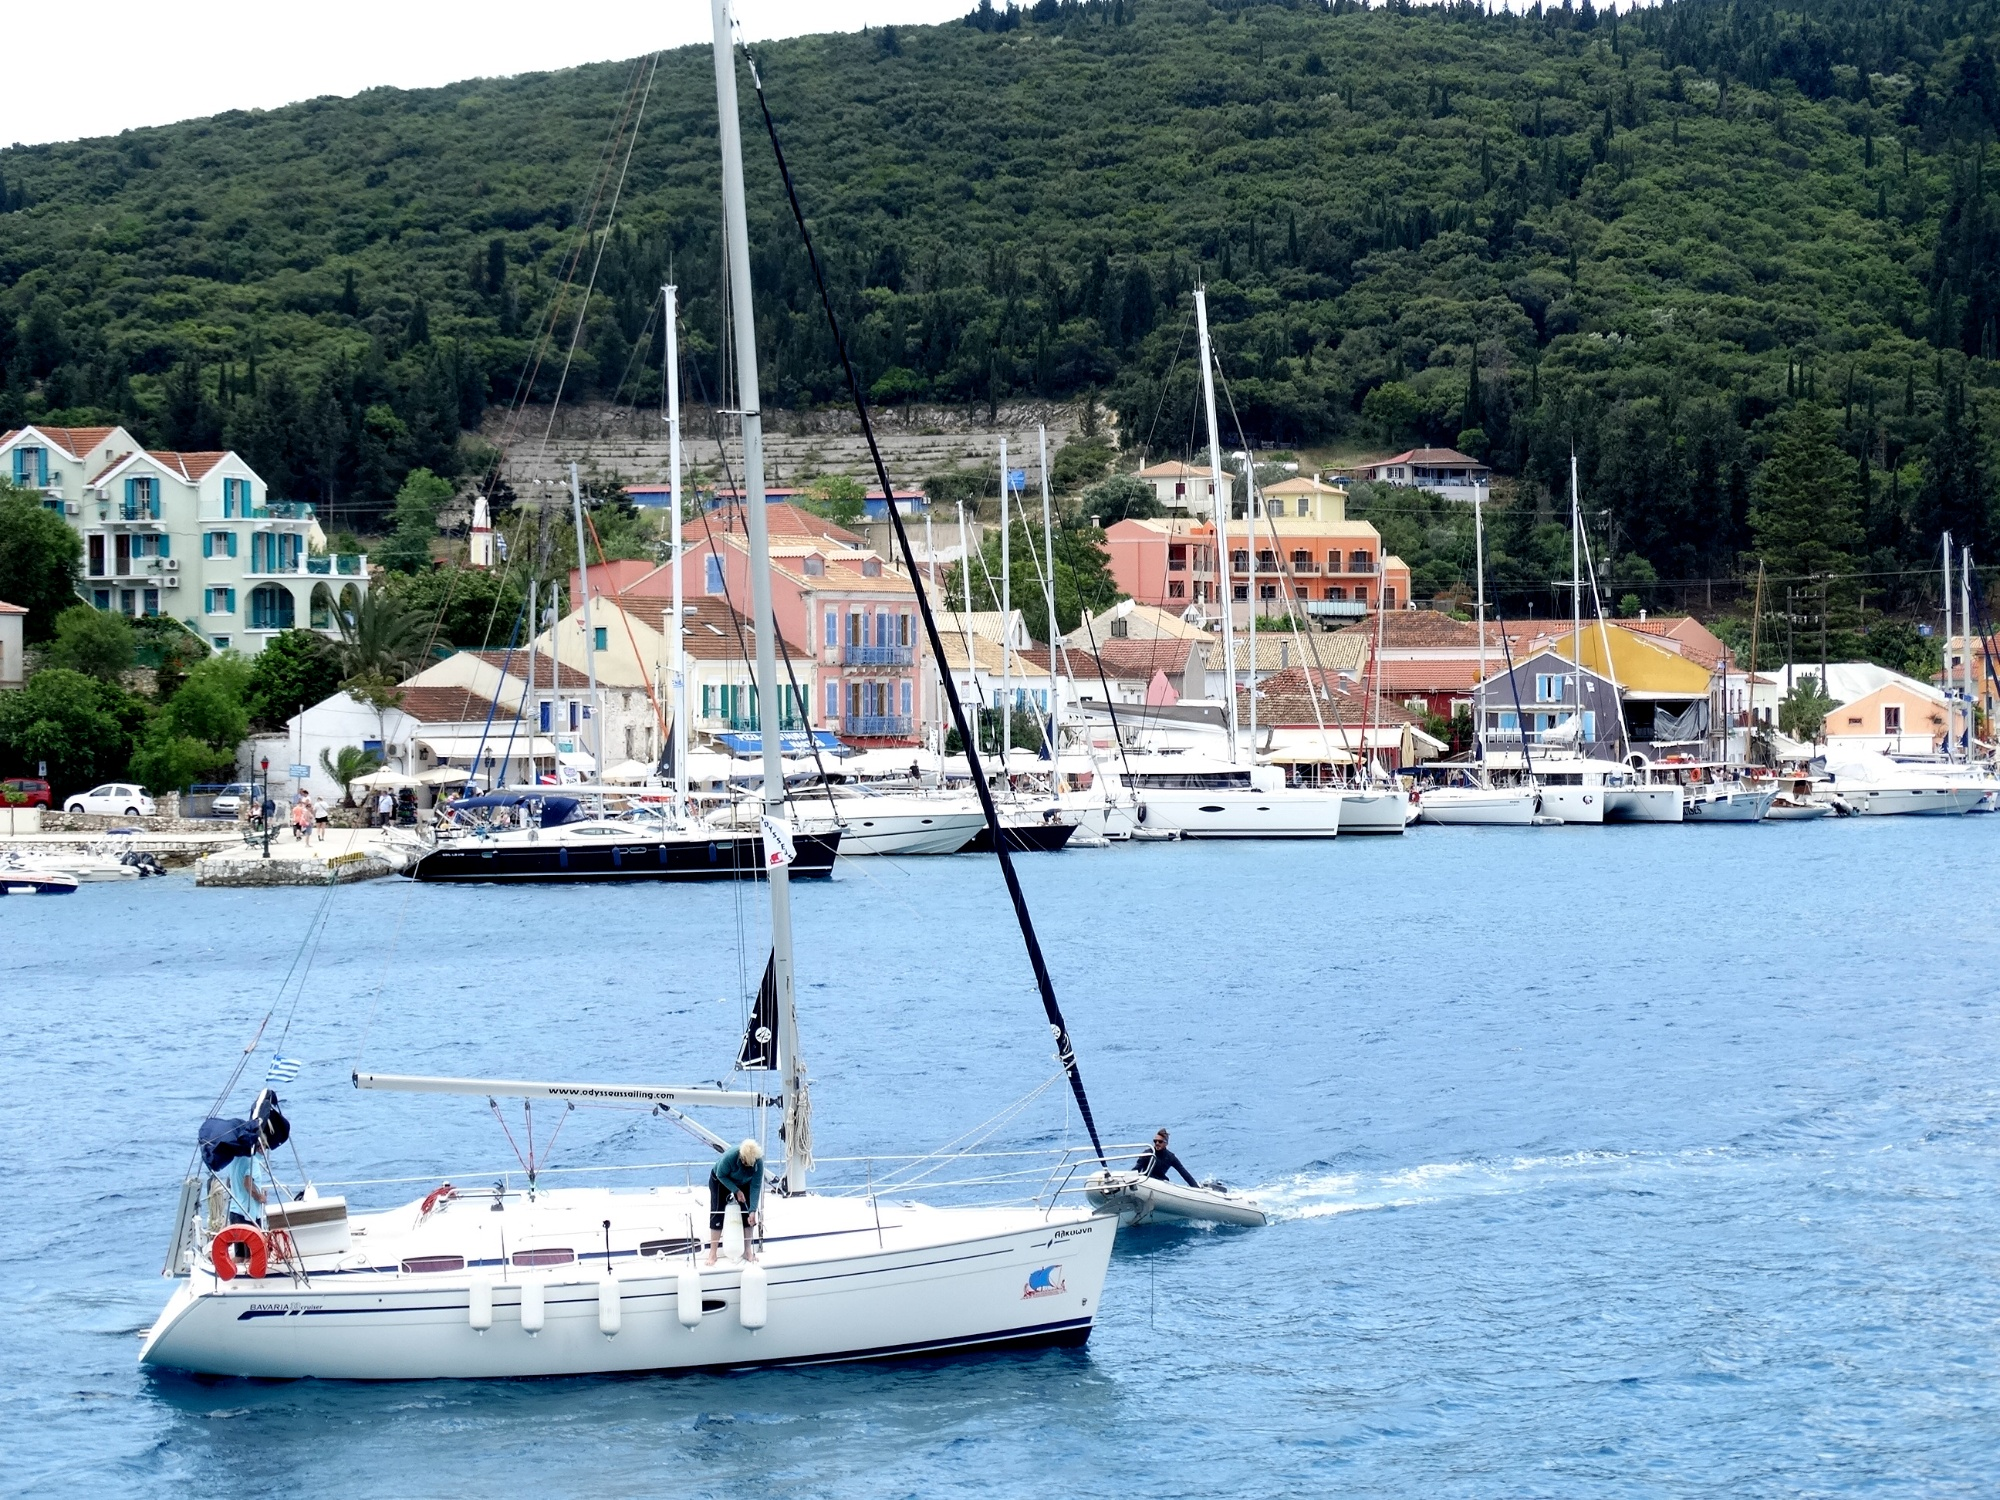Analyze the image in a comprehensive and detailed manner. The image showcases a vibrant harborside scene, likely in a Mediterranean location, where a sleek white sailboat with a blue stripe is preparing to dock or depart. Several individuals are actively working on the deck, hinting at the vessel being well-maintained and possibly ready for a voyage. The harbor is busy with an array of boats moored at the docks, suggesting a popular maritime hub. The backdrop features charming, colorful buildings ascending the hillside—typical of coastal towns in this region, with an assortment of hues from ochre to pastel blues, adding to the locale's picturesque appeal. The hill is lush with greenery, perhaps indicating the time of year with full foliage. Above, the sky is overcast, and although the image doesn't convey the mood effectively, if it were slightly brighter, this could imply a calm yet lively atmosphere ideal for sailing. The snapshot provides a glimpse into the leisurely pace and lifestyle associated with coastal Mediterranean towns. 